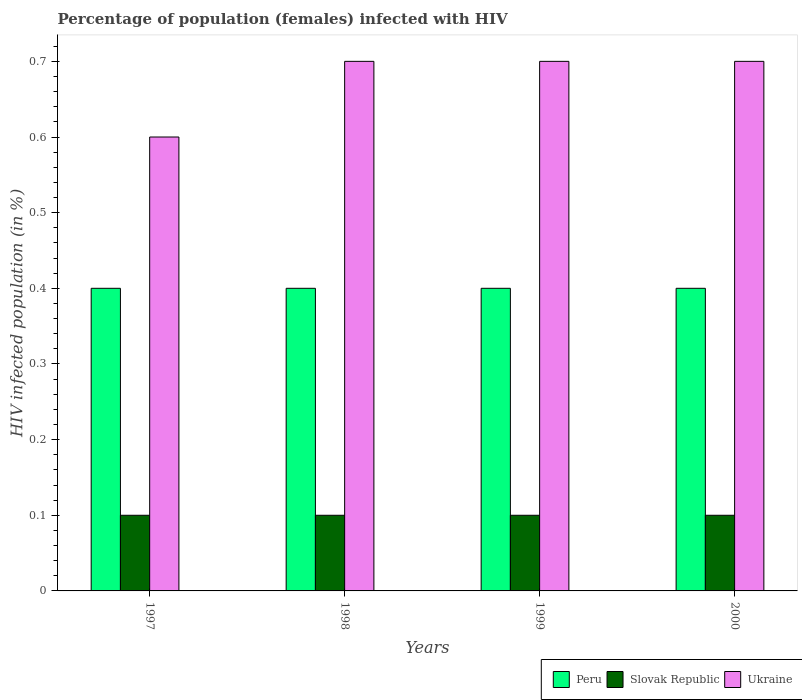How many groups of bars are there?
Give a very brief answer. 4. Are the number of bars per tick equal to the number of legend labels?
Ensure brevity in your answer.  Yes. How many bars are there on the 3rd tick from the right?
Make the answer very short. 3. In how many cases, is the number of bars for a given year not equal to the number of legend labels?
Provide a succinct answer. 0. What is the percentage of HIV infected female population in Slovak Republic in 2000?
Your answer should be compact. 0.1. In which year was the percentage of HIV infected female population in Slovak Republic maximum?
Give a very brief answer. 1997. What is the total percentage of HIV infected female population in Peru in the graph?
Offer a terse response. 1.6. What is the difference between the percentage of HIV infected female population in Ukraine in 2000 and the percentage of HIV infected female population in Peru in 1998?
Provide a succinct answer. 0.3. In how many years, is the percentage of HIV infected female population in Slovak Republic greater than 0.44 %?
Keep it short and to the point. 0. What is the ratio of the percentage of HIV infected female population in Ukraine in 1999 to that in 2000?
Offer a terse response. 1. In how many years, is the percentage of HIV infected female population in Ukraine greater than the average percentage of HIV infected female population in Ukraine taken over all years?
Ensure brevity in your answer.  3. Is the sum of the percentage of HIV infected female population in Slovak Republic in 1999 and 2000 greater than the maximum percentage of HIV infected female population in Ukraine across all years?
Make the answer very short. No. What does the 2nd bar from the left in 1999 represents?
Keep it short and to the point. Slovak Republic. How many bars are there?
Make the answer very short. 12. Are all the bars in the graph horizontal?
Make the answer very short. No. How many years are there in the graph?
Offer a terse response. 4. Are the values on the major ticks of Y-axis written in scientific E-notation?
Offer a very short reply. No. How many legend labels are there?
Keep it short and to the point. 3. What is the title of the graph?
Keep it short and to the point. Percentage of population (females) infected with HIV. What is the label or title of the Y-axis?
Make the answer very short. HIV infected population (in %). What is the HIV infected population (in %) in Ukraine in 1997?
Your answer should be compact. 0.6. What is the HIV infected population (in %) in Peru in 1998?
Your answer should be very brief. 0.4. What is the HIV infected population (in %) in Slovak Republic in 1998?
Provide a succinct answer. 0.1. What is the HIV infected population (in %) in Slovak Republic in 1999?
Your answer should be compact. 0.1. What is the HIV infected population (in %) of Ukraine in 1999?
Offer a terse response. 0.7. What is the HIV infected population (in %) in Ukraine in 2000?
Provide a short and direct response. 0.7. Across all years, what is the maximum HIV infected population (in %) of Peru?
Offer a very short reply. 0.4. Across all years, what is the minimum HIV infected population (in %) in Ukraine?
Ensure brevity in your answer.  0.6. What is the total HIV infected population (in %) in Peru in the graph?
Your answer should be compact. 1.6. What is the total HIV infected population (in %) of Ukraine in the graph?
Give a very brief answer. 2.7. What is the difference between the HIV infected population (in %) in Slovak Republic in 1997 and that in 1998?
Keep it short and to the point. 0. What is the difference between the HIV infected population (in %) in Slovak Republic in 1997 and that in 1999?
Make the answer very short. 0. What is the difference between the HIV infected population (in %) of Slovak Republic in 1997 and that in 2000?
Give a very brief answer. 0. What is the difference between the HIV infected population (in %) of Peru in 1998 and that in 1999?
Make the answer very short. 0. What is the difference between the HIV infected population (in %) in Ukraine in 1998 and that in 1999?
Provide a succinct answer. 0. What is the difference between the HIV infected population (in %) of Slovak Republic in 1998 and that in 2000?
Provide a short and direct response. 0. What is the difference between the HIV infected population (in %) of Ukraine in 1998 and that in 2000?
Keep it short and to the point. 0. What is the difference between the HIV infected population (in %) in Slovak Republic in 1999 and that in 2000?
Offer a terse response. 0. What is the difference between the HIV infected population (in %) of Ukraine in 1999 and that in 2000?
Offer a terse response. 0. What is the difference between the HIV infected population (in %) of Slovak Republic in 1997 and the HIV infected population (in %) of Ukraine in 1998?
Provide a succinct answer. -0.6. What is the difference between the HIV infected population (in %) in Slovak Republic in 1997 and the HIV infected population (in %) in Ukraine in 2000?
Keep it short and to the point. -0.6. What is the difference between the HIV infected population (in %) of Peru in 1998 and the HIV infected population (in %) of Slovak Republic in 1999?
Ensure brevity in your answer.  0.3. What is the difference between the HIV infected population (in %) of Peru in 1998 and the HIV infected population (in %) of Ukraine in 1999?
Provide a succinct answer. -0.3. What is the difference between the HIV infected population (in %) of Slovak Republic in 1998 and the HIV infected population (in %) of Ukraine in 1999?
Offer a terse response. -0.6. What is the difference between the HIV infected population (in %) of Slovak Republic in 1998 and the HIV infected population (in %) of Ukraine in 2000?
Your answer should be compact. -0.6. What is the difference between the HIV infected population (in %) of Peru in 1999 and the HIV infected population (in %) of Slovak Republic in 2000?
Your answer should be very brief. 0.3. What is the difference between the HIV infected population (in %) in Peru in 1999 and the HIV infected population (in %) in Ukraine in 2000?
Give a very brief answer. -0.3. What is the difference between the HIV infected population (in %) in Slovak Republic in 1999 and the HIV infected population (in %) in Ukraine in 2000?
Your answer should be compact. -0.6. What is the average HIV infected population (in %) in Slovak Republic per year?
Make the answer very short. 0.1. What is the average HIV infected population (in %) of Ukraine per year?
Offer a very short reply. 0.68. In the year 1997, what is the difference between the HIV infected population (in %) of Peru and HIV infected population (in %) of Slovak Republic?
Your answer should be very brief. 0.3. In the year 1998, what is the difference between the HIV infected population (in %) in Peru and HIV infected population (in %) in Ukraine?
Keep it short and to the point. -0.3. In the year 1999, what is the difference between the HIV infected population (in %) in Peru and HIV infected population (in %) in Ukraine?
Give a very brief answer. -0.3. In the year 2000, what is the difference between the HIV infected population (in %) in Peru and HIV infected population (in %) in Slovak Republic?
Your answer should be very brief. 0.3. In the year 2000, what is the difference between the HIV infected population (in %) of Slovak Republic and HIV infected population (in %) of Ukraine?
Offer a very short reply. -0.6. What is the ratio of the HIV infected population (in %) of Peru in 1997 to that in 1998?
Your response must be concise. 1. What is the ratio of the HIV infected population (in %) of Peru in 1997 to that in 1999?
Your response must be concise. 1. What is the ratio of the HIV infected population (in %) in Peru in 1997 to that in 2000?
Your answer should be compact. 1. What is the ratio of the HIV infected population (in %) of Slovak Republic in 1997 to that in 2000?
Make the answer very short. 1. What is the ratio of the HIV infected population (in %) of Ukraine in 1997 to that in 2000?
Keep it short and to the point. 0.86. What is the ratio of the HIV infected population (in %) of Peru in 1998 to that in 1999?
Keep it short and to the point. 1. What is the ratio of the HIV infected population (in %) in Slovak Republic in 1999 to that in 2000?
Give a very brief answer. 1. What is the difference between the highest and the second highest HIV infected population (in %) in Ukraine?
Offer a very short reply. 0. What is the difference between the highest and the lowest HIV infected population (in %) in Peru?
Give a very brief answer. 0. What is the difference between the highest and the lowest HIV infected population (in %) in Ukraine?
Ensure brevity in your answer.  0.1. 